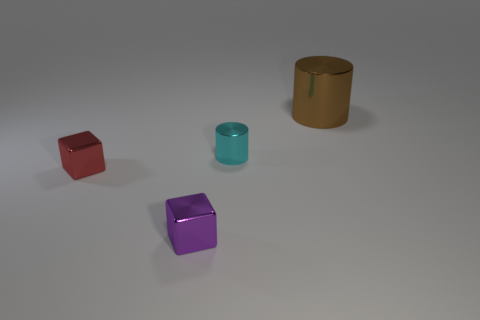Add 2 big brown metal spheres. How many objects exist? 6 Subtract all big shiny things. Subtract all cyan things. How many objects are left? 2 Add 4 purple metal blocks. How many purple metal blocks are left? 5 Add 2 small cyan cylinders. How many small cyan cylinders exist? 3 Subtract 0 red balls. How many objects are left? 4 